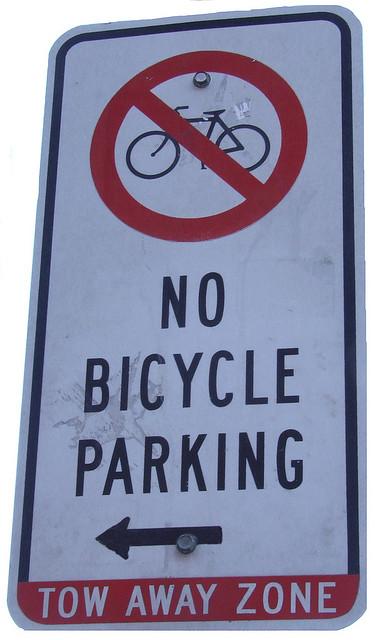What direction is the arrow pointing in?
Answer briefly. Left. What isn't allowed, according to this sign?
Write a very short answer. Bicycle parking. How many cars are in the picture?
Short answer required. 0. 